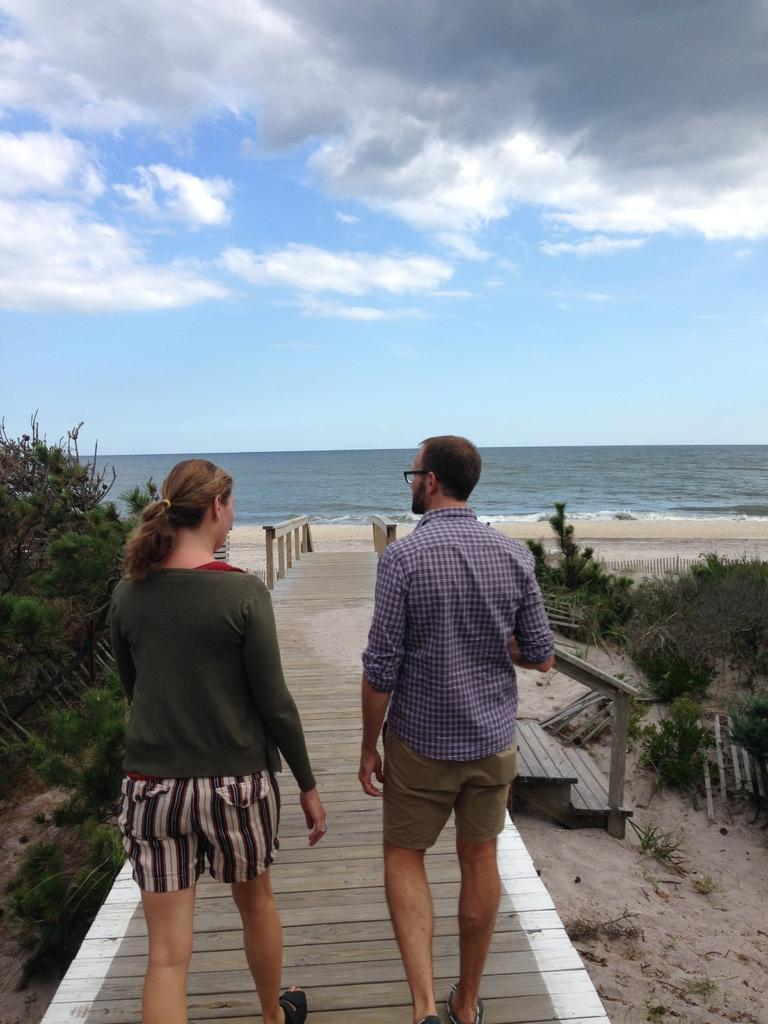Who can be seen in the image? There is a man and a woman in the image. What are they doing in the image? They are walking on a walkway. What type of vegetation is present in the image? There are plants in the image. What else can be seen in the image besides the people and plants? There is water visible in the image. What is visible at the top of the image? The sky is visible at the top of the image. What arithmetic problem is the man solving in the image? There is no indication in the image that the man is solving an arithmetic problem. What type of dirt can be seen on the walkway in the image? There is no dirt visible on the walkway in the image. 